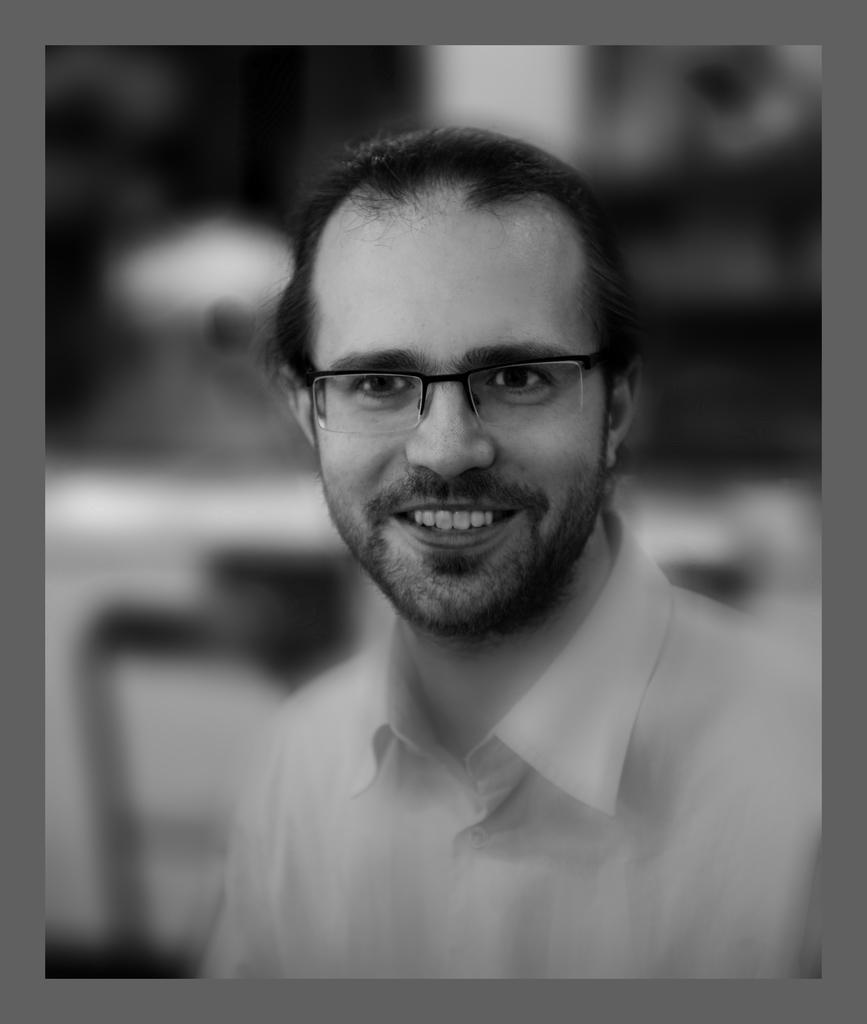Can you describe this image briefly? It is a black and white image. In this image we can see a man wearing the glasses and smiling. The image has borders and the background of the image is blurred. 